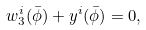Convert formula to latex. <formula><loc_0><loc_0><loc_500><loc_500>w _ { 3 } ^ { i } ( \bar { \phi } ) + y ^ { i } ( \bar { \phi } ) = 0 ,</formula> 